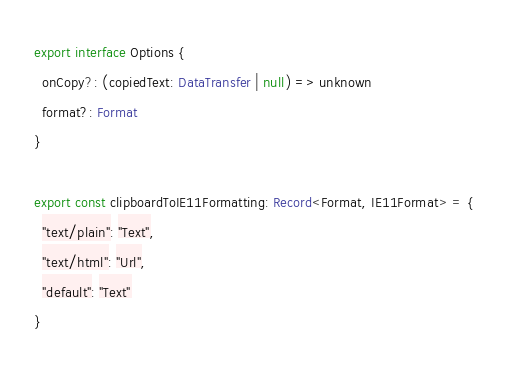Convert code to text. <code><loc_0><loc_0><loc_500><loc_500><_TypeScript_>
export interface Options {
  onCopy?: (copiedText: DataTransfer | null) => unknown
  format?: Format
}

export const clipboardToIE11Formatting: Record<Format, IE11Format> = {
  "text/plain": "Text",
  "text/html": "Url",
  "default": "Text"
}
</code> 